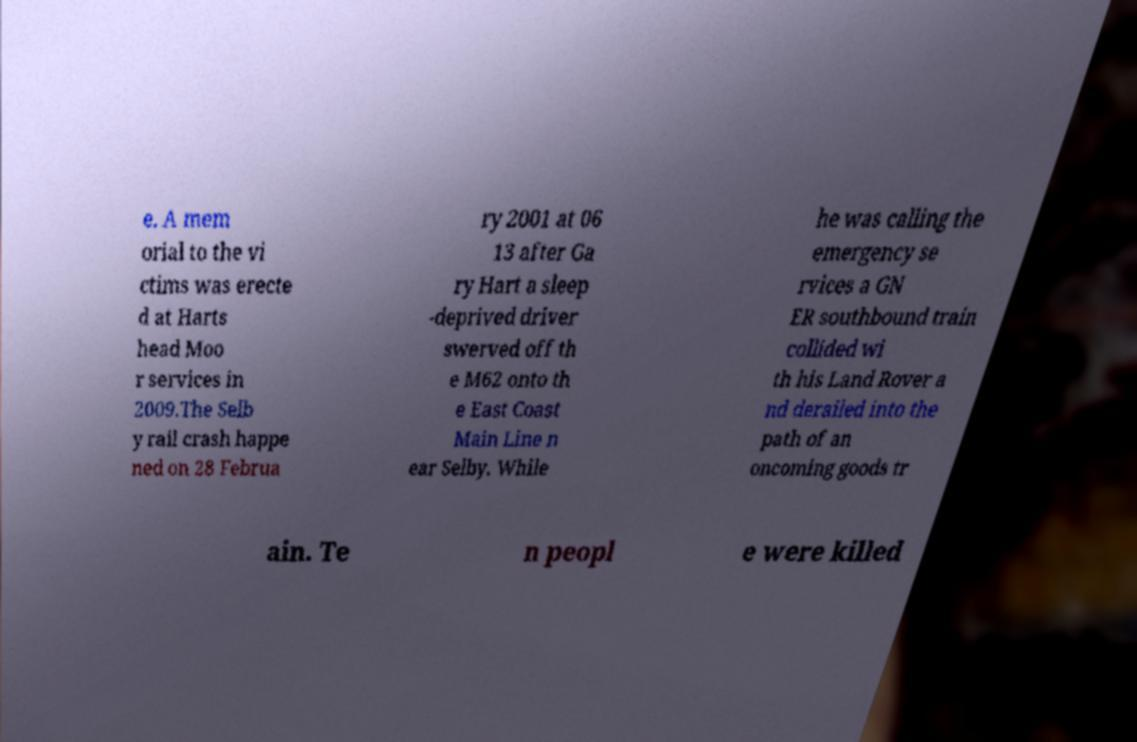Please identify and transcribe the text found in this image. e. A mem orial to the vi ctims was erecte d at Harts head Moo r services in 2009.The Selb y rail crash happe ned on 28 Februa ry 2001 at 06 13 after Ga ry Hart a sleep -deprived driver swerved off th e M62 onto th e East Coast Main Line n ear Selby. While he was calling the emergency se rvices a GN ER southbound train collided wi th his Land Rover a nd derailed into the path of an oncoming goods tr ain. Te n peopl e were killed 